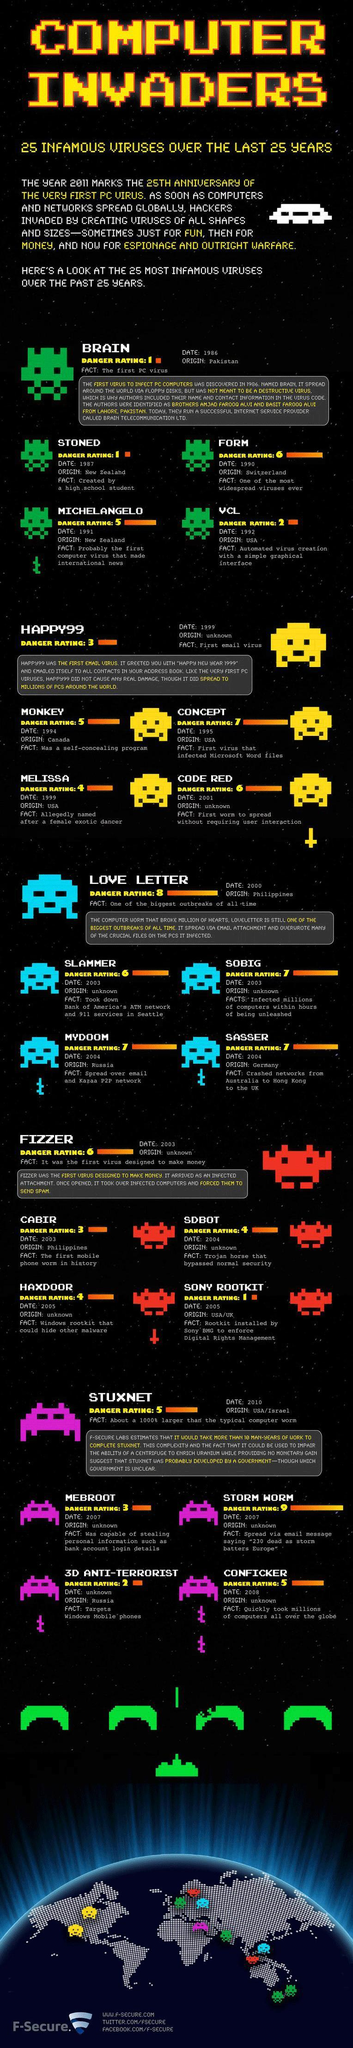How many viruses have a danger rating of 6?
Answer the question with a short phrase. 4 How many viruses have a danger rating of 7? 4 List the name of the viruses which have a danger rating of 2? VCL, Anti-Terrorist List the name of the viruses which have a danger rating of 3? Happy99, Cabir, Mebroot 